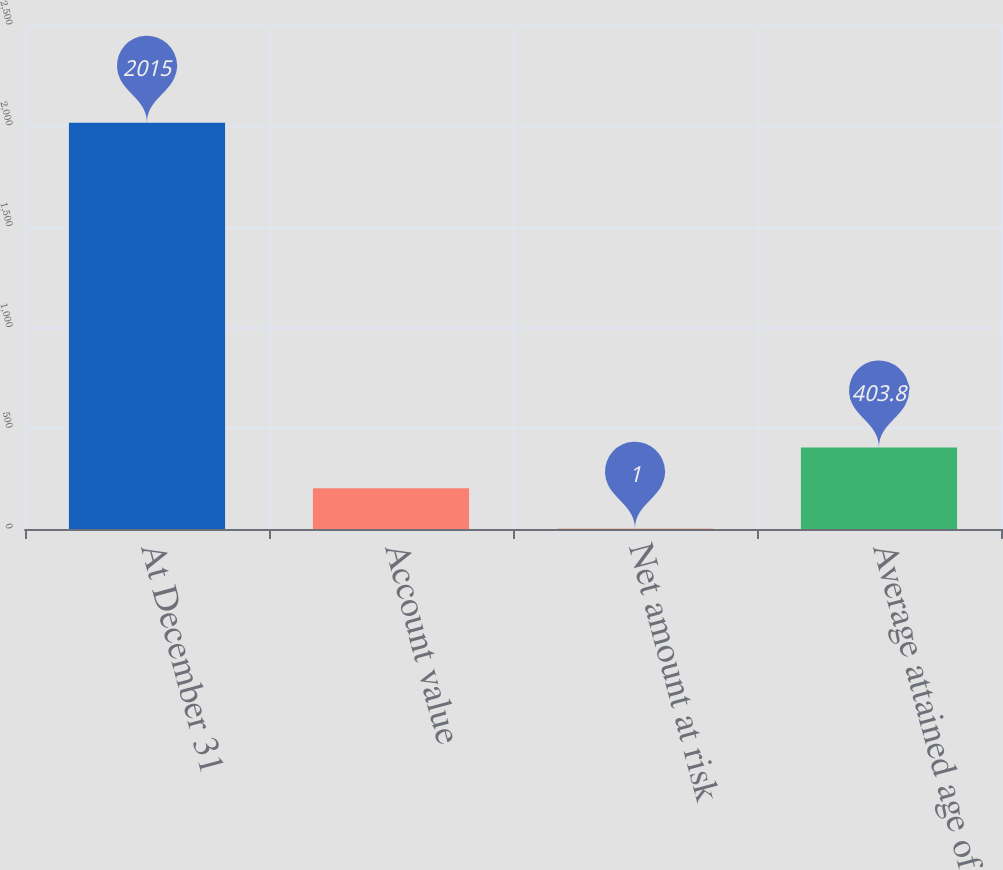<chart> <loc_0><loc_0><loc_500><loc_500><bar_chart><fcel>At December 31<fcel>Account value<fcel>Net amount at risk<fcel>Average attained age of<nl><fcel>2015<fcel>202.4<fcel>1<fcel>403.8<nl></chart> 